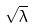Convert formula to latex. <formula><loc_0><loc_0><loc_500><loc_500>\sqrt { \lambda }</formula> 